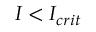<formula> <loc_0><loc_0><loc_500><loc_500>I < I _ { c r i t }</formula> 